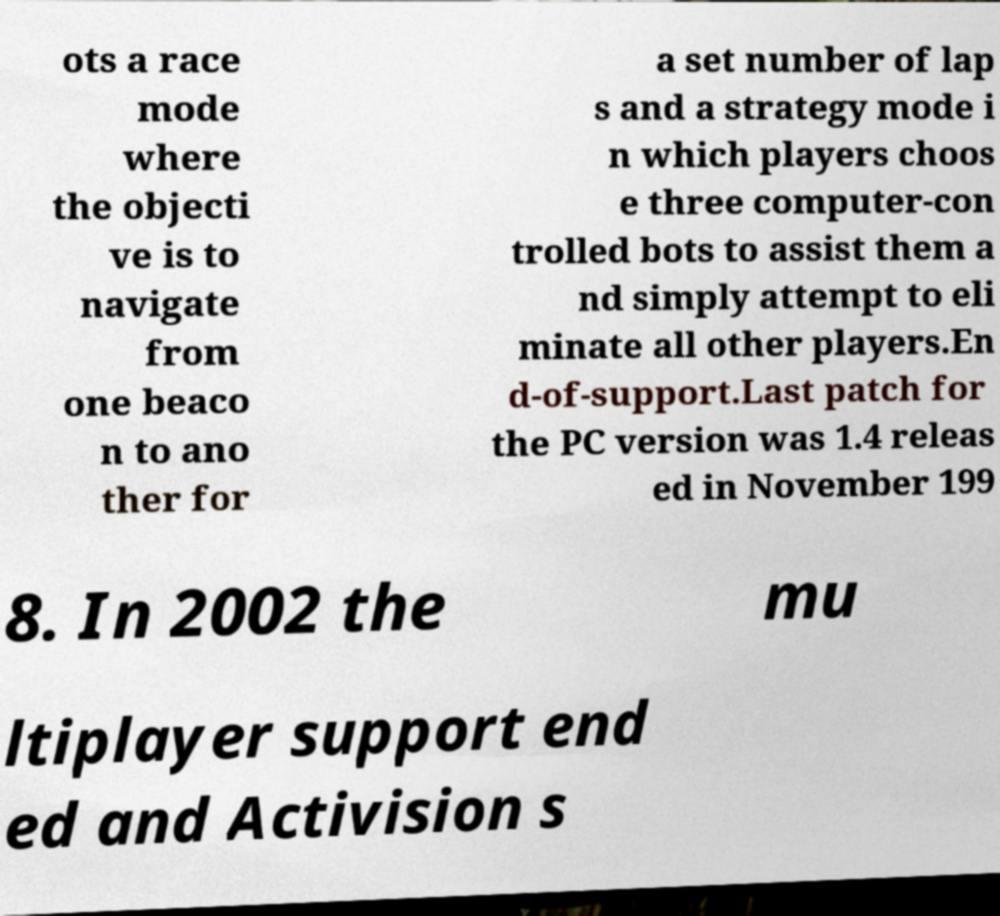Can you read and provide the text displayed in the image?This photo seems to have some interesting text. Can you extract and type it out for me? ots a race mode where the objecti ve is to navigate from one beaco n to ano ther for a set number of lap s and a strategy mode i n which players choos e three computer-con trolled bots to assist them a nd simply attempt to eli minate all other players.En d-of-support.Last patch for the PC version was 1.4 releas ed in November 199 8. In 2002 the mu ltiplayer support end ed and Activision s 